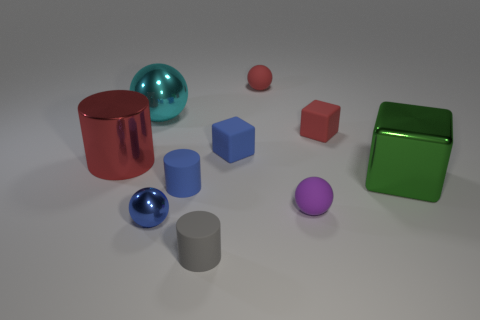Subtract all tiny metallic spheres. How many spheres are left? 3 Subtract all cyan spheres. How many spheres are left? 3 Subtract all blue spheres. How many green blocks are left? 1 Add 8 large red shiny cylinders. How many large red shiny cylinders are left? 9 Add 9 purple balls. How many purple balls exist? 10 Subtract 1 blue cylinders. How many objects are left? 9 Subtract all cylinders. How many objects are left? 7 Subtract 2 spheres. How many spheres are left? 2 Subtract all cyan cubes. Subtract all cyan cylinders. How many cubes are left? 3 Subtract all tiny purple metallic cylinders. Subtract all small blue cylinders. How many objects are left? 9 